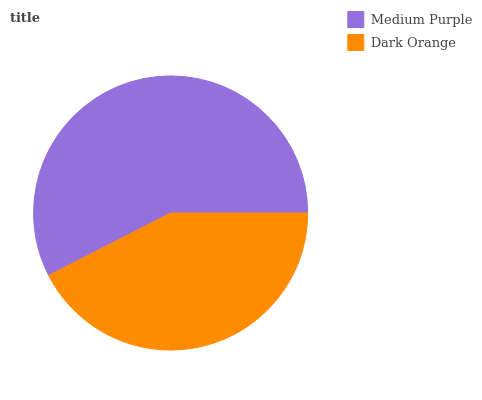Is Dark Orange the minimum?
Answer yes or no. Yes. Is Medium Purple the maximum?
Answer yes or no. Yes. Is Dark Orange the maximum?
Answer yes or no. No. Is Medium Purple greater than Dark Orange?
Answer yes or no. Yes. Is Dark Orange less than Medium Purple?
Answer yes or no. Yes. Is Dark Orange greater than Medium Purple?
Answer yes or no. No. Is Medium Purple less than Dark Orange?
Answer yes or no. No. Is Medium Purple the high median?
Answer yes or no. Yes. Is Dark Orange the low median?
Answer yes or no. Yes. Is Dark Orange the high median?
Answer yes or no. No. Is Medium Purple the low median?
Answer yes or no. No. 